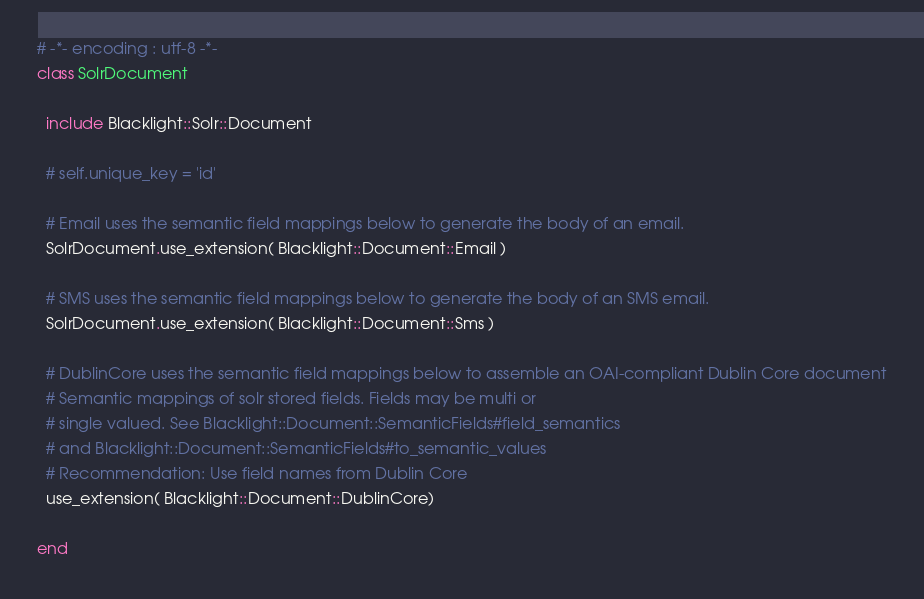Convert code to text. <code><loc_0><loc_0><loc_500><loc_500><_Ruby_># -*- encoding : utf-8 -*-
class SolrDocument 

  include Blacklight::Solr::Document

  # self.unique_key = 'id'
  
  # Email uses the semantic field mappings below to generate the body of an email.
  SolrDocument.use_extension( Blacklight::Document::Email )
  
  # SMS uses the semantic field mappings below to generate the body of an SMS email.
  SolrDocument.use_extension( Blacklight::Document::Sms )

  # DublinCore uses the semantic field mappings below to assemble an OAI-compliant Dublin Core document
  # Semantic mappings of solr stored fields. Fields may be multi or
  # single valued. See Blacklight::Document::SemanticFields#field_semantics
  # and Blacklight::Document::SemanticFields#to_semantic_values
  # Recommendation: Use field names from Dublin Core
  use_extension( Blacklight::Document::DublinCore)    

end
</code> 